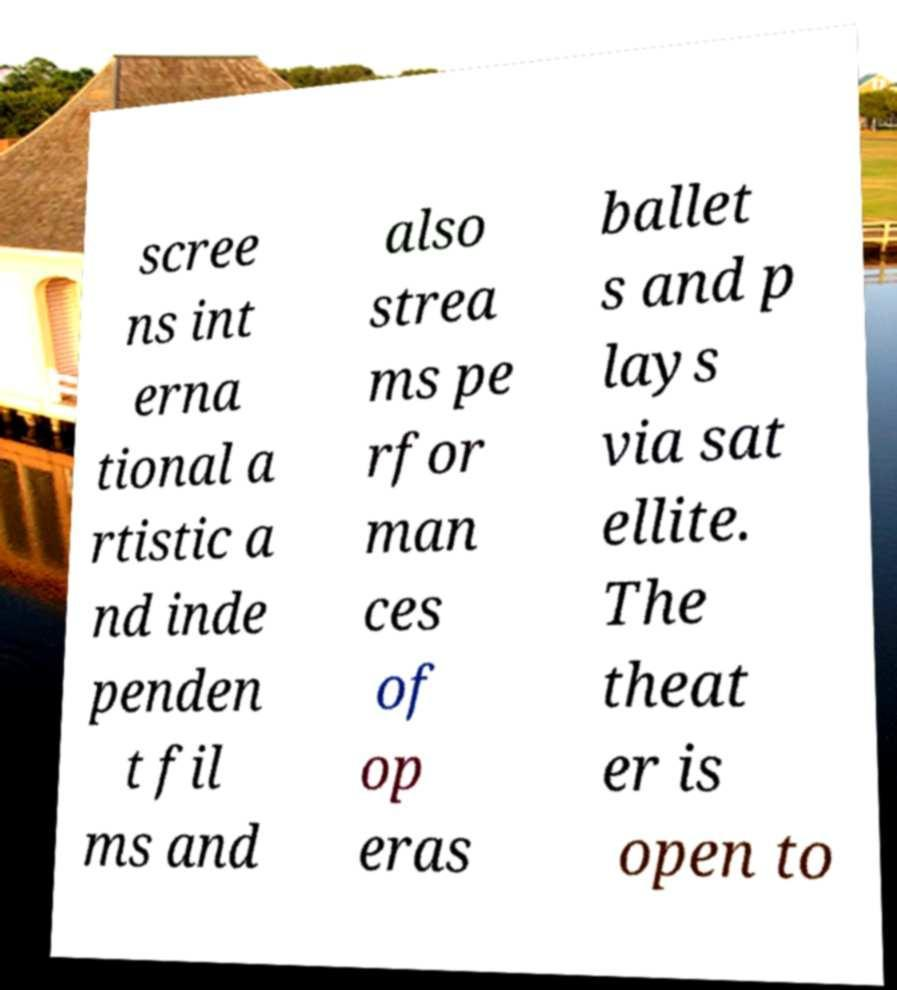Could you assist in decoding the text presented in this image and type it out clearly? scree ns int erna tional a rtistic a nd inde penden t fil ms and also strea ms pe rfor man ces of op eras ballet s and p lays via sat ellite. The theat er is open to 